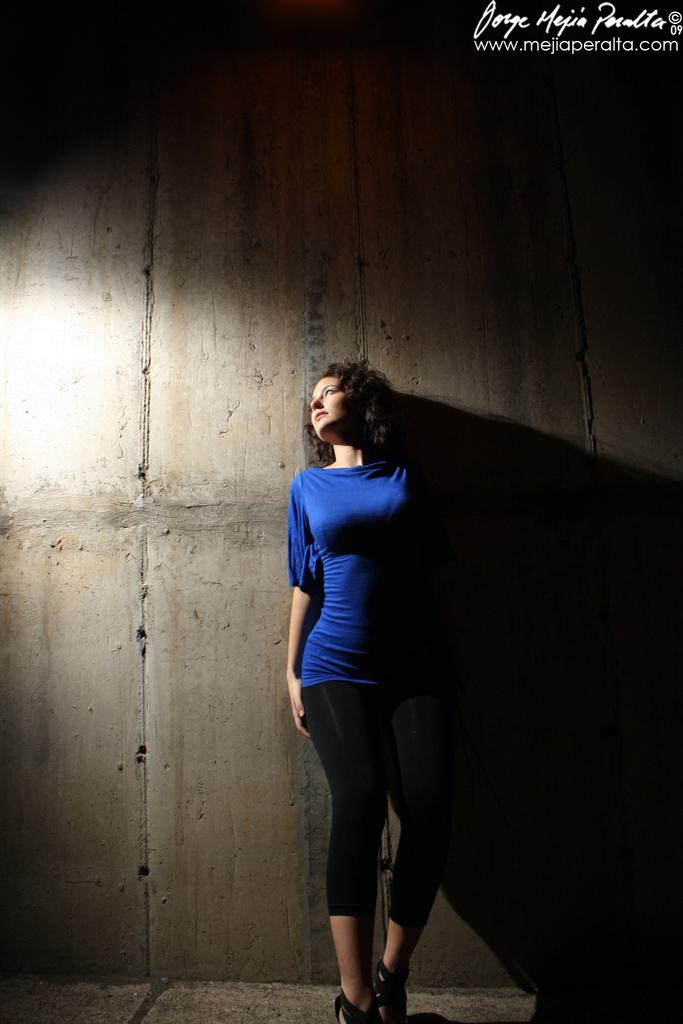Who is the main subject in the image? There is a lady in the image. What is the lady doing in the image? The lady is standing on the floor. What can be seen in the background of the image? There is a wall in the background of the image. What type of bears can be seen interacting with the lady in the image? There are no bears present in the image; it features a lady standing on the floor with a wall in the background. 